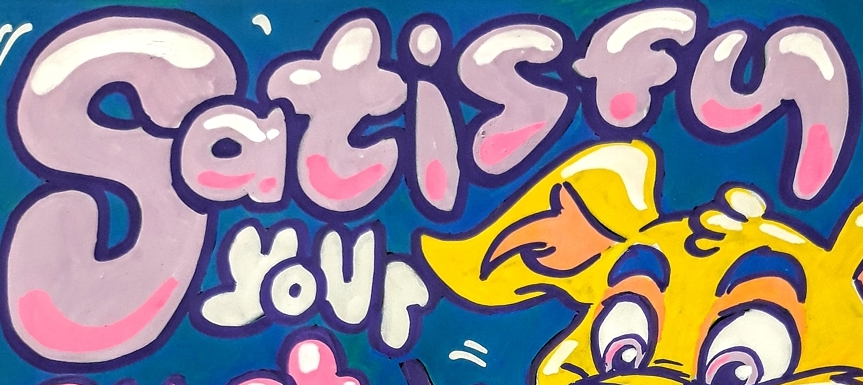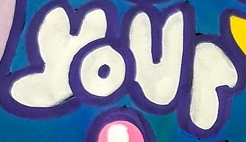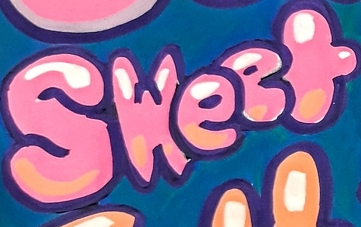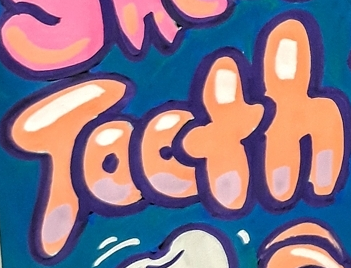Identify the words shown in these images in order, separated by a semicolon. Satisfy; your; Sweet; Tooth 